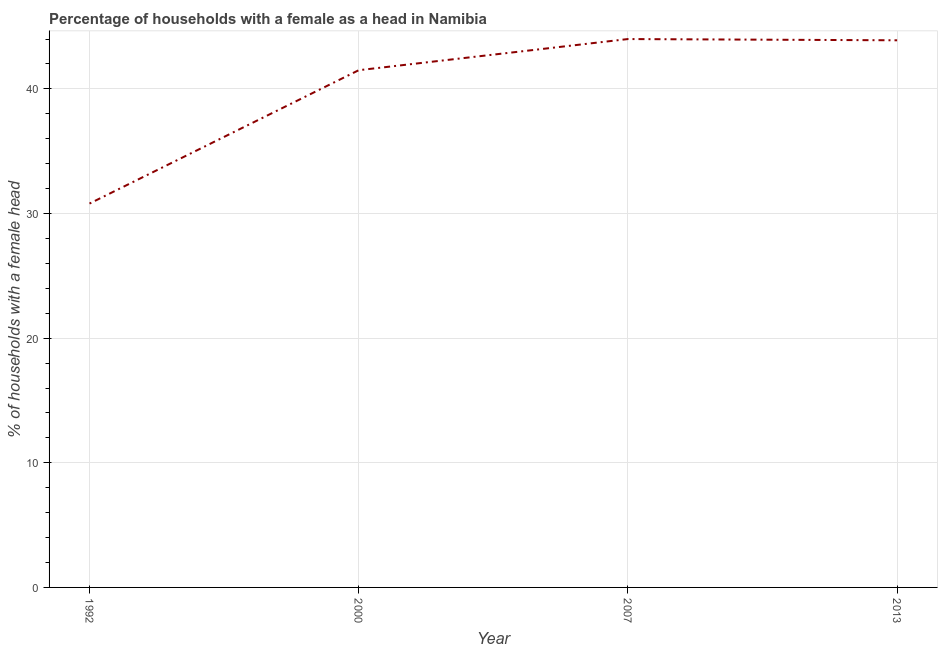What is the number of female supervised households in 2000?
Your response must be concise. 41.5. Across all years, what is the minimum number of female supervised households?
Make the answer very short. 30.8. In which year was the number of female supervised households maximum?
Ensure brevity in your answer.  2007. What is the sum of the number of female supervised households?
Your answer should be very brief. 160.2. What is the difference between the number of female supervised households in 1992 and 2007?
Provide a succinct answer. -13.2. What is the average number of female supervised households per year?
Your response must be concise. 40.05. What is the median number of female supervised households?
Your answer should be very brief. 42.7. In how many years, is the number of female supervised households greater than 32 %?
Ensure brevity in your answer.  3. What is the ratio of the number of female supervised households in 2000 to that in 2007?
Offer a very short reply. 0.94. Is the difference between the number of female supervised households in 1992 and 2000 greater than the difference between any two years?
Your response must be concise. No. What is the difference between the highest and the second highest number of female supervised households?
Offer a very short reply. 0.1. What is the difference between the highest and the lowest number of female supervised households?
Offer a very short reply. 13.2. How many lines are there?
Offer a terse response. 1. Does the graph contain grids?
Provide a succinct answer. Yes. What is the title of the graph?
Give a very brief answer. Percentage of households with a female as a head in Namibia. What is the label or title of the X-axis?
Provide a short and direct response. Year. What is the label or title of the Y-axis?
Offer a terse response. % of households with a female head. What is the % of households with a female head in 1992?
Make the answer very short. 30.8. What is the % of households with a female head of 2000?
Give a very brief answer. 41.5. What is the % of households with a female head in 2013?
Your answer should be very brief. 43.9. What is the difference between the % of households with a female head in 1992 and 2000?
Make the answer very short. -10.7. What is the difference between the % of households with a female head in 2000 and 2007?
Ensure brevity in your answer.  -2.5. What is the difference between the % of households with a female head in 2007 and 2013?
Your answer should be compact. 0.1. What is the ratio of the % of households with a female head in 1992 to that in 2000?
Your answer should be compact. 0.74. What is the ratio of the % of households with a female head in 1992 to that in 2007?
Offer a very short reply. 0.7. What is the ratio of the % of households with a female head in 1992 to that in 2013?
Provide a short and direct response. 0.7. What is the ratio of the % of households with a female head in 2000 to that in 2007?
Ensure brevity in your answer.  0.94. What is the ratio of the % of households with a female head in 2000 to that in 2013?
Make the answer very short. 0.94. What is the ratio of the % of households with a female head in 2007 to that in 2013?
Your answer should be compact. 1. 